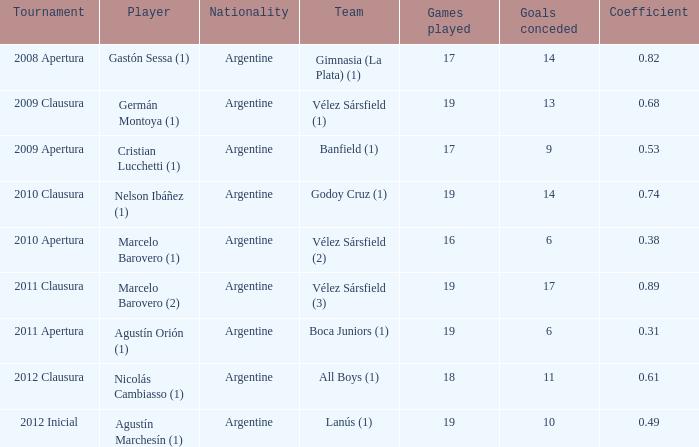Can you parse all the data within this table? {'header': ['Tournament', 'Player', 'Nationality', 'Team', 'Games played', 'Goals conceded', 'Coefficient'], 'rows': [['2008 Apertura', 'Gastón Sessa (1)', 'Argentine', 'Gimnasia (La Plata) (1)', '17', '14', '0.82'], ['2009 Clausura', 'Germán Montoya (1)', 'Argentine', 'Vélez Sársfield (1)', '19', '13', '0.68'], ['2009 Apertura', 'Cristian Lucchetti (1)', 'Argentine', 'Banfield (1)', '17', '9', '0.53'], ['2010 Clausura', 'Nelson Ibáñez (1)', 'Argentine', 'Godoy Cruz (1)', '19', '14', '0.74'], ['2010 Apertura', 'Marcelo Barovero (1)', 'Argentine', 'Vélez Sársfield (2)', '16', '6', '0.38'], ['2011 Clausura', 'Marcelo Barovero (2)', 'Argentine', 'Vélez Sársfield (3)', '19', '17', '0.89'], ['2011 Apertura', 'Agustín Orión (1)', 'Argentine', 'Boca Juniors (1)', '19', '6', '0.31'], ['2012 Clausura', 'Nicolás Cambiasso (1)', 'Argentine', 'All Boys (1)', '18', '11', '0.61'], ['2012 Inicial', 'Agustín Marchesín (1)', 'Argentine', 'Lanús (1)', '19', '10', '0.49']]}  the 2010 clausura tournament? 0.74. 